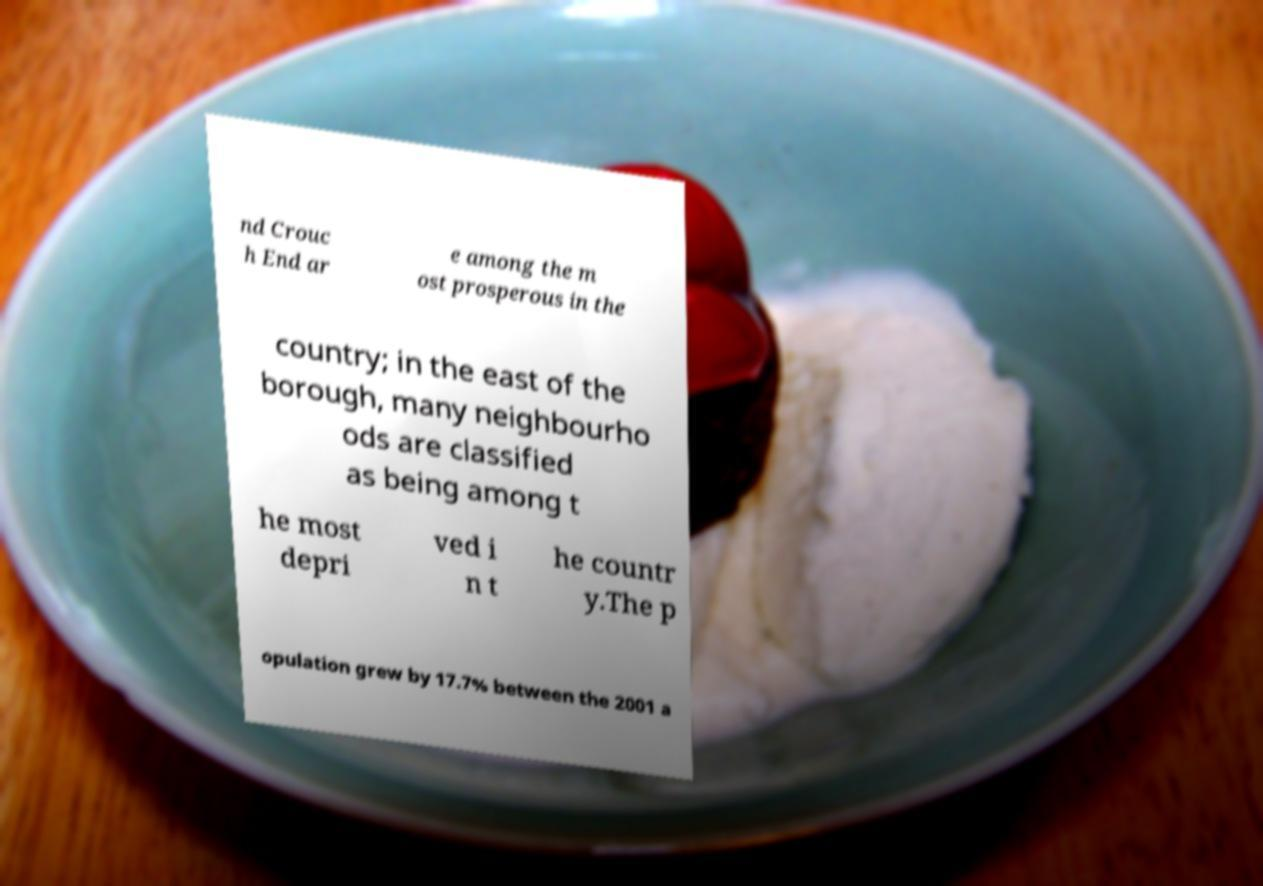I need the written content from this picture converted into text. Can you do that? nd Crouc h End ar e among the m ost prosperous in the country; in the east of the borough, many neighbourho ods are classified as being among t he most depri ved i n t he countr y.The p opulation grew by 17.7% between the 2001 a 